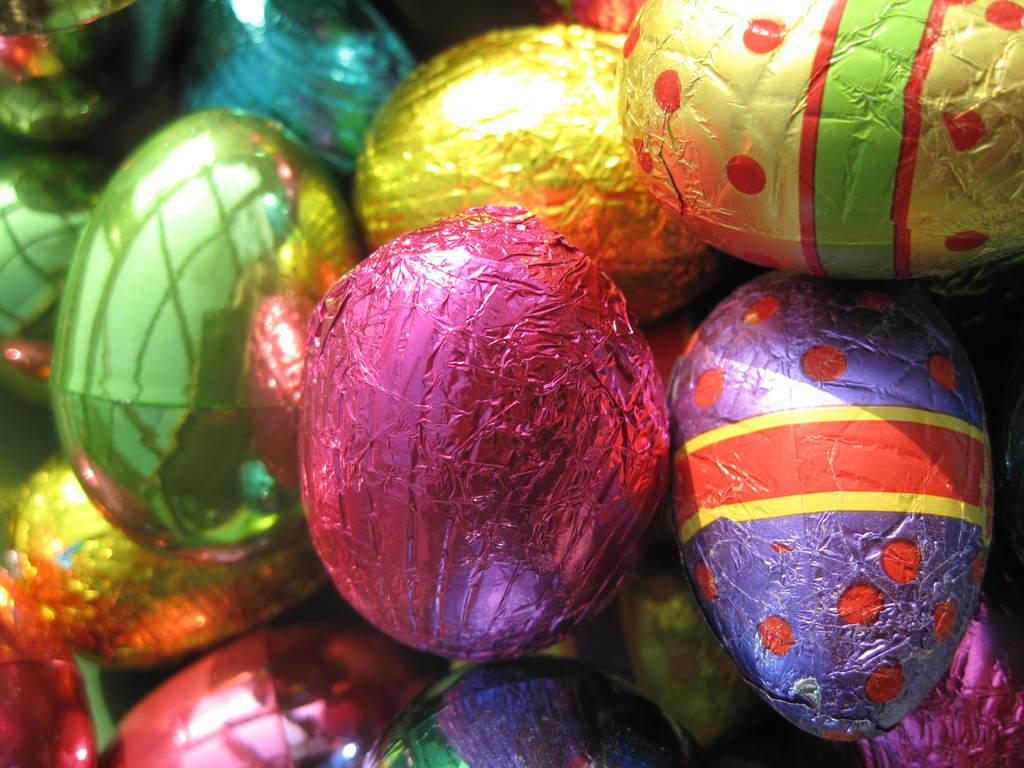What shapes can be seen in the image? There are circular objects in the image. Are the circular objects modified in any way? Some of the circular objects are covered with decorative papers. What type of poison is being used to decorate the circular objects in the image? There is no poison present in the image; the circular objects are covered with decorative papers. 